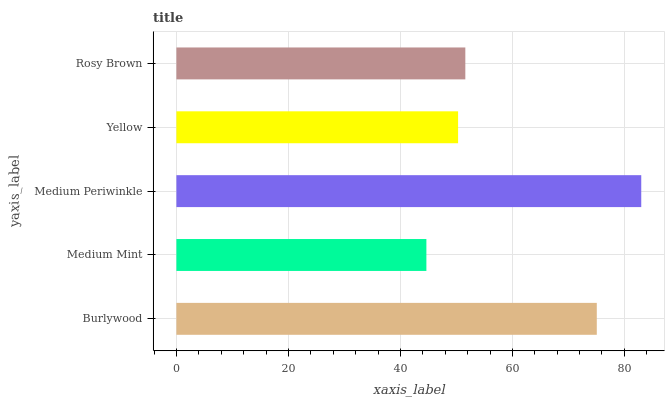Is Medium Mint the minimum?
Answer yes or no. Yes. Is Medium Periwinkle the maximum?
Answer yes or no. Yes. Is Medium Periwinkle the minimum?
Answer yes or no. No. Is Medium Mint the maximum?
Answer yes or no. No. Is Medium Periwinkle greater than Medium Mint?
Answer yes or no. Yes. Is Medium Mint less than Medium Periwinkle?
Answer yes or no. Yes. Is Medium Mint greater than Medium Periwinkle?
Answer yes or no. No. Is Medium Periwinkle less than Medium Mint?
Answer yes or no. No. Is Rosy Brown the high median?
Answer yes or no. Yes. Is Rosy Brown the low median?
Answer yes or no. Yes. Is Medium Mint the high median?
Answer yes or no. No. Is Yellow the low median?
Answer yes or no. No. 